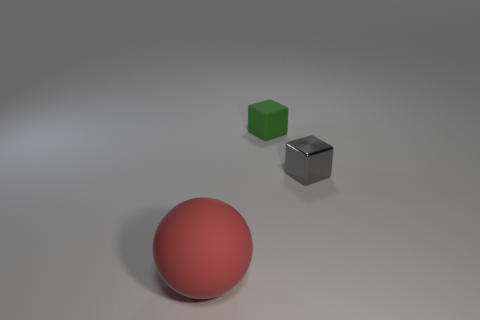Subtract all spheres. How many objects are left? 2 Subtract 1 spheres. How many spheres are left? 0 Subtract all small brown rubber balls. Subtract all gray shiny objects. How many objects are left? 2 Add 2 small metal cubes. How many small metal cubes are left? 3 Add 1 tiny green cylinders. How many tiny green cylinders exist? 1 Add 1 small gray blocks. How many objects exist? 4 Subtract all gray blocks. How many blocks are left? 1 Subtract 1 green cubes. How many objects are left? 2 Subtract all cyan balls. Subtract all green blocks. How many balls are left? 1 Subtract all brown balls. How many cyan blocks are left? 0 